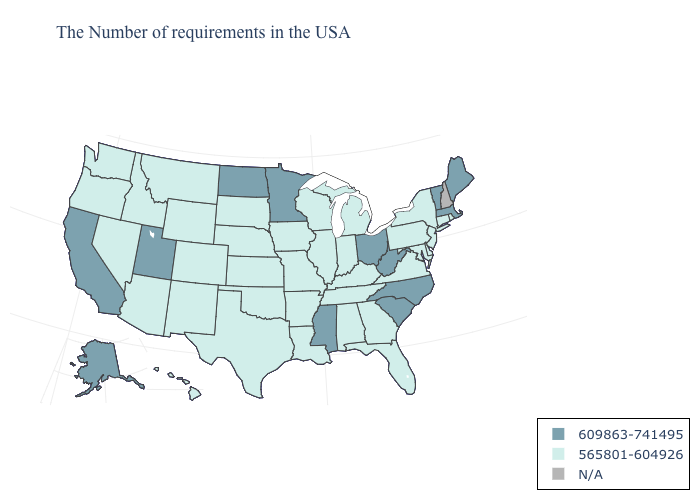Does Maine have the highest value in the Northeast?
Quick response, please. Yes. Among the states that border Pennsylvania , does New York have the highest value?
Give a very brief answer. No. Among the states that border Arizona , does Nevada have the highest value?
Short answer required. No. What is the value of Ohio?
Concise answer only. 609863-741495. What is the value of Minnesota?
Concise answer only. 609863-741495. Among the states that border Texas , which have the lowest value?
Be succinct. Louisiana, Arkansas, Oklahoma, New Mexico. Is the legend a continuous bar?
Give a very brief answer. No. Does Oklahoma have the highest value in the USA?
Answer briefly. No. Is the legend a continuous bar?
Short answer required. No. What is the value of Alaska?
Short answer required. 609863-741495. Which states hav the highest value in the MidWest?
Write a very short answer. Ohio, Minnesota, North Dakota. Name the states that have a value in the range N/A?
Keep it brief. New Hampshire. Does Ohio have the lowest value in the MidWest?
Keep it brief. No. What is the highest value in the Northeast ?
Give a very brief answer. 609863-741495. What is the value of Oregon?
Concise answer only. 565801-604926. 